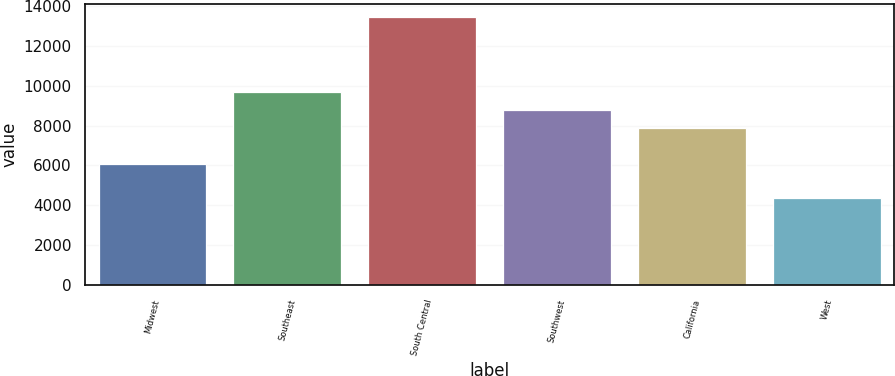<chart> <loc_0><loc_0><loc_500><loc_500><bar_chart><fcel>Midwest<fcel>Southeast<fcel>South Central<fcel>Southwest<fcel>California<fcel>West<nl><fcel>6050<fcel>9704.6<fcel>13444<fcel>8794.3<fcel>7884<fcel>4341<nl></chart> 